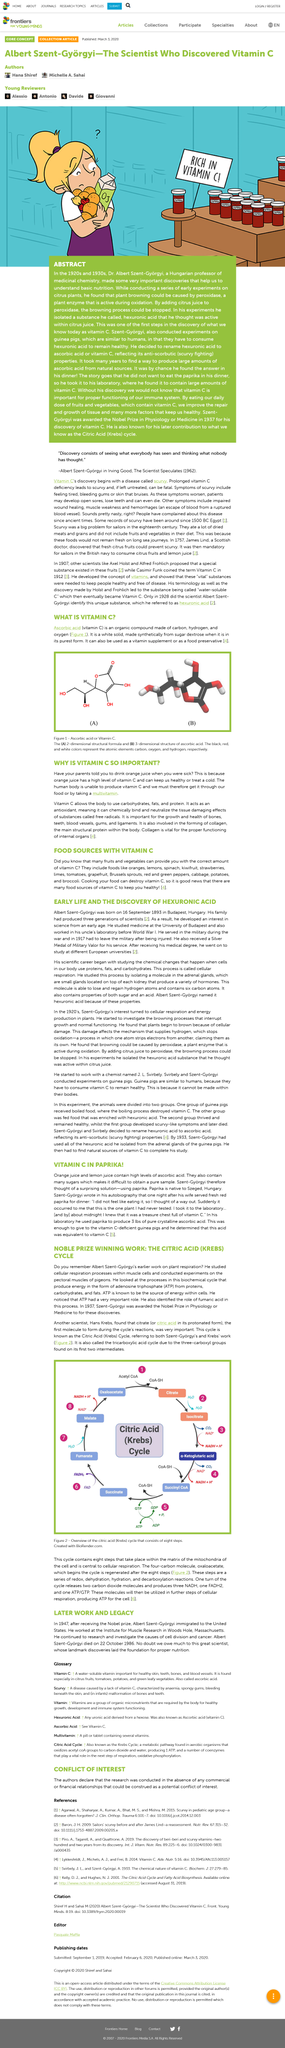Identify some key points in this picture. The ATP is the primary source of energy within cells, providing cells with the necessary energy to carry out vital functions. The tricarboxylic acid cycle, also known as the Krebs cycle or citric acid cycle, is a metabolic pathway that occurs in the mitochondria of cells. It is a series of chemical reactions that produce energy in the form of ATP. The cycle involves a series of intermediate compounds, which undergo several chemical transformations before generating energy. The first two intermediates of the cycle are isocitrate and alpha-ketoglutarate, which both contain three carboxyl groups. Yes, bleeding gums is a symptom of scurvy. In 1937, Dr. Szent-Gyorgyi was awarded the Nobel Prize in Physiology or Medicine for his significant contributions to the field. Albert Szent-Györgi began his scientific career by studying the chemical changes that occur in the body when cells are protected by proteins, fats, and carbohydrates. 